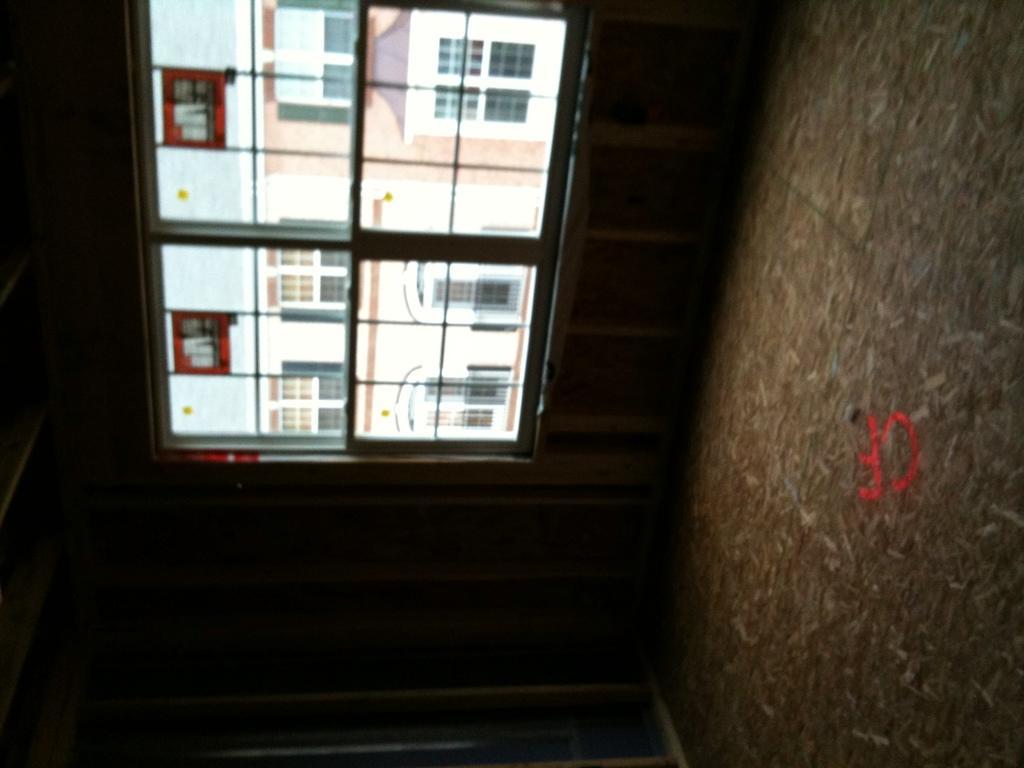Could you give a brief overview of what you see in this image? In the center of the image there is a window. To the right side of the image there is wall. 